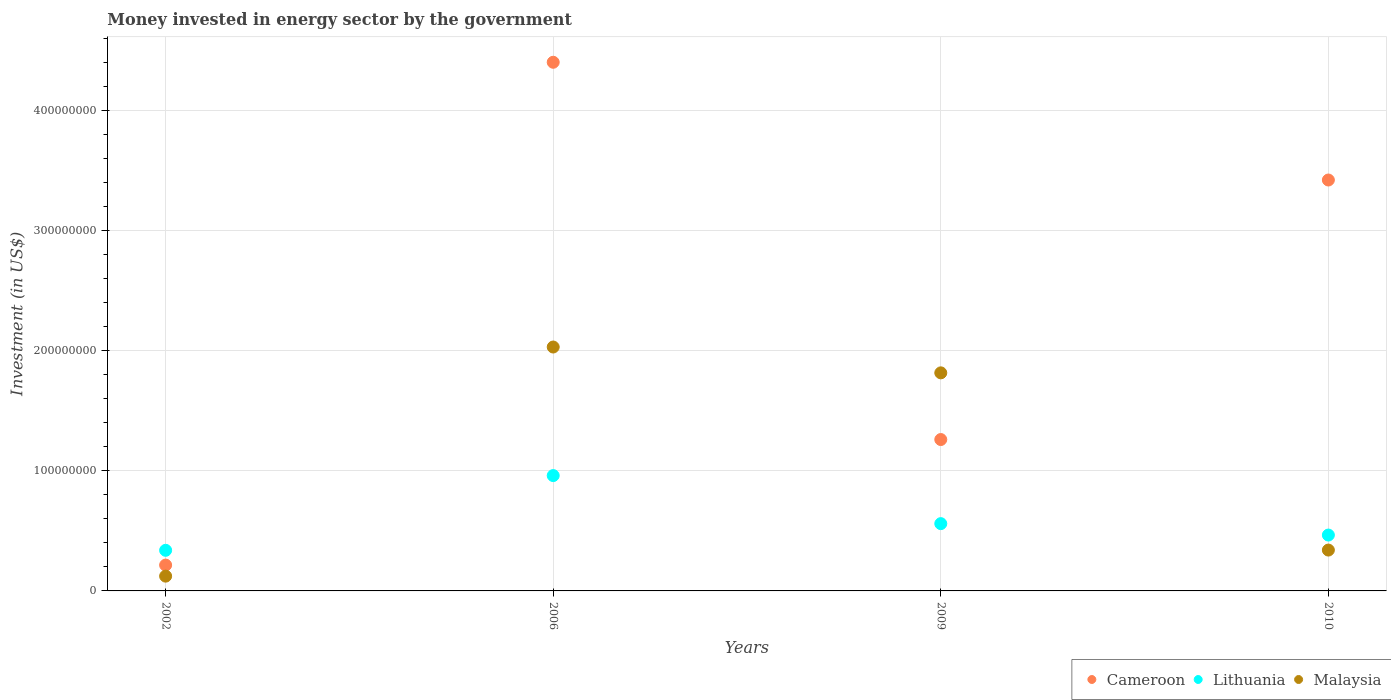What is the money spent in energy sector in Cameroon in 2010?
Offer a terse response. 3.42e+08. Across all years, what is the maximum money spent in energy sector in Malaysia?
Your response must be concise. 2.03e+08. Across all years, what is the minimum money spent in energy sector in Lithuania?
Ensure brevity in your answer.  3.38e+07. What is the total money spent in energy sector in Cameroon in the graph?
Your answer should be compact. 9.30e+08. What is the difference between the money spent in energy sector in Lithuania in 2009 and that in 2010?
Your answer should be very brief. 9.50e+06. What is the difference between the money spent in energy sector in Cameroon in 2006 and the money spent in energy sector in Malaysia in 2002?
Offer a very short reply. 4.28e+08. What is the average money spent in energy sector in Cameroon per year?
Your response must be concise. 2.32e+08. In the year 2009, what is the difference between the money spent in energy sector in Malaysia and money spent in energy sector in Cameroon?
Offer a very short reply. 5.55e+07. In how many years, is the money spent in energy sector in Lithuania greater than 340000000 US$?
Offer a very short reply. 0. What is the ratio of the money spent in energy sector in Malaysia in 2002 to that in 2009?
Make the answer very short. 0.07. Is the money spent in energy sector in Malaysia in 2002 less than that in 2009?
Your answer should be very brief. Yes. Is the difference between the money spent in energy sector in Malaysia in 2002 and 2009 greater than the difference between the money spent in energy sector in Cameroon in 2002 and 2009?
Your answer should be very brief. No. What is the difference between the highest and the second highest money spent in energy sector in Lithuania?
Give a very brief answer. 4.00e+07. What is the difference between the highest and the lowest money spent in energy sector in Lithuania?
Keep it short and to the point. 6.22e+07. Is it the case that in every year, the sum of the money spent in energy sector in Cameroon and money spent in energy sector in Malaysia  is greater than the money spent in energy sector in Lithuania?
Give a very brief answer. No. Are the values on the major ticks of Y-axis written in scientific E-notation?
Keep it short and to the point. No. Where does the legend appear in the graph?
Provide a succinct answer. Bottom right. How are the legend labels stacked?
Make the answer very short. Horizontal. What is the title of the graph?
Ensure brevity in your answer.  Money invested in energy sector by the government. Does "Ethiopia" appear as one of the legend labels in the graph?
Your answer should be compact. No. What is the label or title of the X-axis?
Provide a short and direct response. Years. What is the label or title of the Y-axis?
Provide a short and direct response. Investment (in US$). What is the Investment (in US$) of Cameroon in 2002?
Give a very brief answer. 2.15e+07. What is the Investment (in US$) in Lithuania in 2002?
Ensure brevity in your answer.  3.38e+07. What is the Investment (in US$) of Malaysia in 2002?
Ensure brevity in your answer.  1.23e+07. What is the Investment (in US$) in Cameroon in 2006?
Your response must be concise. 4.40e+08. What is the Investment (in US$) of Lithuania in 2006?
Your answer should be compact. 9.60e+07. What is the Investment (in US$) of Malaysia in 2006?
Offer a very short reply. 2.03e+08. What is the Investment (in US$) in Cameroon in 2009?
Your response must be concise. 1.26e+08. What is the Investment (in US$) in Lithuania in 2009?
Your response must be concise. 5.60e+07. What is the Investment (in US$) of Malaysia in 2009?
Make the answer very short. 1.82e+08. What is the Investment (in US$) in Cameroon in 2010?
Provide a short and direct response. 3.42e+08. What is the Investment (in US$) in Lithuania in 2010?
Offer a terse response. 4.65e+07. What is the Investment (in US$) in Malaysia in 2010?
Give a very brief answer. 3.40e+07. Across all years, what is the maximum Investment (in US$) in Cameroon?
Offer a terse response. 4.40e+08. Across all years, what is the maximum Investment (in US$) of Lithuania?
Offer a very short reply. 9.60e+07. Across all years, what is the maximum Investment (in US$) in Malaysia?
Your answer should be very brief. 2.03e+08. Across all years, what is the minimum Investment (in US$) of Cameroon?
Offer a very short reply. 2.15e+07. Across all years, what is the minimum Investment (in US$) of Lithuania?
Make the answer very short. 3.38e+07. Across all years, what is the minimum Investment (in US$) of Malaysia?
Give a very brief answer. 1.23e+07. What is the total Investment (in US$) of Cameroon in the graph?
Ensure brevity in your answer.  9.30e+08. What is the total Investment (in US$) of Lithuania in the graph?
Your answer should be very brief. 2.32e+08. What is the total Investment (in US$) of Malaysia in the graph?
Your answer should be very brief. 4.31e+08. What is the difference between the Investment (in US$) in Cameroon in 2002 and that in 2006?
Your response must be concise. -4.18e+08. What is the difference between the Investment (in US$) of Lithuania in 2002 and that in 2006?
Make the answer very short. -6.22e+07. What is the difference between the Investment (in US$) of Malaysia in 2002 and that in 2006?
Provide a short and direct response. -1.91e+08. What is the difference between the Investment (in US$) in Cameroon in 2002 and that in 2009?
Keep it short and to the point. -1.04e+08. What is the difference between the Investment (in US$) in Lithuania in 2002 and that in 2009?
Make the answer very short. -2.22e+07. What is the difference between the Investment (in US$) of Malaysia in 2002 and that in 2009?
Your answer should be very brief. -1.69e+08. What is the difference between the Investment (in US$) of Cameroon in 2002 and that in 2010?
Your answer should be compact. -3.20e+08. What is the difference between the Investment (in US$) of Lithuania in 2002 and that in 2010?
Give a very brief answer. -1.27e+07. What is the difference between the Investment (in US$) of Malaysia in 2002 and that in 2010?
Your answer should be very brief. -2.17e+07. What is the difference between the Investment (in US$) of Cameroon in 2006 and that in 2009?
Ensure brevity in your answer.  3.14e+08. What is the difference between the Investment (in US$) in Lithuania in 2006 and that in 2009?
Your response must be concise. 4.00e+07. What is the difference between the Investment (in US$) of Malaysia in 2006 and that in 2009?
Ensure brevity in your answer.  2.15e+07. What is the difference between the Investment (in US$) in Cameroon in 2006 and that in 2010?
Keep it short and to the point. 9.80e+07. What is the difference between the Investment (in US$) in Lithuania in 2006 and that in 2010?
Provide a short and direct response. 4.95e+07. What is the difference between the Investment (in US$) of Malaysia in 2006 and that in 2010?
Keep it short and to the point. 1.69e+08. What is the difference between the Investment (in US$) in Cameroon in 2009 and that in 2010?
Your answer should be very brief. -2.16e+08. What is the difference between the Investment (in US$) in Lithuania in 2009 and that in 2010?
Offer a very short reply. 9.50e+06. What is the difference between the Investment (in US$) of Malaysia in 2009 and that in 2010?
Give a very brief answer. 1.48e+08. What is the difference between the Investment (in US$) in Cameroon in 2002 and the Investment (in US$) in Lithuania in 2006?
Give a very brief answer. -7.45e+07. What is the difference between the Investment (in US$) in Cameroon in 2002 and the Investment (in US$) in Malaysia in 2006?
Your response must be concise. -1.82e+08. What is the difference between the Investment (in US$) in Lithuania in 2002 and the Investment (in US$) in Malaysia in 2006?
Provide a succinct answer. -1.69e+08. What is the difference between the Investment (in US$) in Cameroon in 2002 and the Investment (in US$) in Lithuania in 2009?
Ensure brevity in your answer.  -3.45e+07. What is the difference between the Investment (in US$) in Cameroon in 2002 and the Investment (in US$) in Malaysia in 2009?
Your answer should be very brief. -1.60e+08. What is the difference between the Investment (in US$) of Lithuania in 2002 and the Investment (in US$) of Malaysia in 2009?
Ensure brevity in your answer.  -1.48e+08. What is the difference between the Investment (in US$) of Cameroon in 2002 and the Investment (in US$) of Lithuania in 2010?
Provide a succinct answer. -2.50e+07. What is the difference between the Investment (in US$) of Cameroon in 2002 and the Investment (in US$) of Malaysia in 2010?
Your response must be concise. -1.25e+07. What is the difference between the Investment (in US$) in Lithuania in 2002 and the Investment (in US$) in Malaysia in 2010?
Give a very brief answer. -2.00e+05. What is the difference between the Investment (in US$) of Cameroon in 2006 and the Investment (in US$) of Lithuania in 2009?
Provide a short and direct response. 3.84e+08. What is the difference between the Investment (in US$) of Cameroon in 2006 and the Investment (in US$) of Malaysia in 2009?
Offer a terse response. 2.58e+08. What is the difference between the Investment (in US$) of Lithuania in 2006 and the Investment (in US$) of Malaysia in 2009?
Your response must be concise. -8.55e+07. What is the difference between the Investment (in US$) in Cameroon in 2006 and the Investment (in US$) in Lithuania in 2010?
Offer a very short reply. 3.94e+08. What is the difference between the Investment (in US$) of Cameroon in 2006 and the Investment (in US$) of Malaysia in 2010?
Your answer should be compact. 4.06e+08. What is the difference between the Investment (in US$) of Lithuania in 2006 and the Investment (in US$) of Malaysia in 2010?
Your answer should be compact. 6.20e+07. What is the difference between the Investment (in US$) of Cameroon in 2009 and the Investment (in US$) of Lithuania in 2010?
Make the answer very short. 7.95e+07. What is the difference between the Investment (in US$) in Cameroon in 2009 and the Investment (in US$) in Malaysia in 2010?
Keep it short and to the point. 9.20e+07. What is the difference between the Investment (in US$) in Lithuania in 2009 and the Investment (in US$) in Malaysia in 2010?
Ensure brevity in your answer.  2.20e+07. What is the average Investment (in US$) in Cameroon per year?
Offer a very short reply. 2.32e+08. What is the average Investment (in US$) in Lithuania per year?
Offer a very short reply. 5.81e+07. What is the average Investment (in US$) of Malaysia per year?
Your answer should be compact. 1.08e+08. In the year 2002, what is the difference between the Investment (in US$) in Cameroon and Investment (in US$) in Lithuania?
Provide a short and direct response. -1.23e+07. In the year 2002, what is the difference between the Investment (in US$) in Cameroon and Investment (in US$) in Malaysia?
Provide a succinct answer. 9.20e+06. In the year 2002, what is the difference between the Investment (in US$) in Lithuania and Investment (in US$) in Malaysia?
Ensure brevity in your answer.  2.15e+07. In the year 2006, what is the difference between the Investment (in US$) in Cameroon and Investment (in US$) in Lithuania?
Offer a very short reply. 3.44e+08. In the year 2006, what is the difference between the Investment (in US$) of Cameroon and Investment (in US$) of Malaysia?
Your answer should be very brief. 2.37e+08. In the year 2006, what is the difference between the Investment (in US$) in Lithuania and Investment (in US$) in Malaysia?
Keep it short and to the point. -1.07e+08. In the year 2009, what is the difference between the Investment (in US$) of Cameroon and Investment (in US$) of Lithuania?
Your answer should be compact. 7.00e+07. In the year 2009, what is the difference between the Investment (in US$) of Cameroon and Investment (in US$) of Malaysia?
Your answer should be very brief. -5.55e+07. In the year 2009, what is the difference between the Investment (in US$) in Lithuania and Investment (in US$) in Malaysia?
Offer a very short reply. -1.26e+08. In the year 2010, what is the difference between the Investment (in US$) of Cameroon and Investment (in US$) of Lithuania?
Keep it short and to the point. 2.96e+08. In the year 2010, what is the difference between the Investment (in US$) of Cameroon and Investment (in US$) of Malaysia?
Offer a terse response. 3.08e+08. In the year 2010, what is the difference between the Investment (in US$) in Lithuania and Investment (in US$) in Malaysia?
Offer a very short reply. 1.25e+07. What is the ratio of the Investment (in US$) in Cameroon in 2002 to that in 2006?
Provide a succinct answer. 0.05. What is the ratio of the Investment (in US$) of Lithuania in 2002 to that in 2006?
Your answer should be very brief. 0.35. What is the ratio of the Investment (in US$) of Malaysia in 2002 to that in 2006?
Keep it short and to the point. 0.06. What is the ratio of the Investment (in US$) of Cameroon in 2002 to that in 2009?
Keep it short and to the point. 0.17. What is the ratio of the Investment (in US$) in Lithuania in 2002 to that in 2009?
Offer a terse response. 0.6. What is the ratio of the Investment (in US$) in Malaysia in 2002 to that in 2009?
Provide a succinct answer. 0.07. What is the ratio of the Investment (in US$) in Cameroon in 2002 to that in 2010?
Offer a very short reply. 0.06. What is the ratio of the Investment (in US$) of Lithuania in 2002 to that in 2010?
Your response must be concise. 0.73. What is the ratio of the Investment (in US$) of Malaysia in 2002 to that in 2010?
Ensure brevity in your answer.  0.36. What is the ratio of the Investment (in US$) of Cameroon in 2006 to that in 2009?
Your answer should be compact. 3.49. What is the ratio of the Investment (in US$) of Lithuania in 2006 to that in 2009?
Keep it short and to the point. 1.71. What is the ratio of the Investment (in US$) of Malaysia in 2006 to that in 2009?
Keep it short and to the point. 1.12. What is the ratio of the Investment (in US$) of Cameroon in 2006 to that in 2010?
Your answer should be very brief. 1.29. What is the ratio of the Investment (in US$) of Lithuania in 2006 to that in 2010?
Ensure brevity in your answer.  2.06. What is the ratio of the Investment (in US$) of Malaysia in 2006 to that in 2010?
Keep it short and to the point. 5.97. What is the ratio of the Investment (in US$) in Cameroon in 2009 to that in 2010?
Offer a very short reply. 0.37. What is the ratio of the Investment (in US$) in Lithuania in 2009 to that in 2010?
Make the answer very short. 1.2. What is the ratio of the Investment (in US$) in Malaysia in 2009 to that in 2010?
Offer a terse response. 5.34. What is the difference between the highest and the second highest Investment (in US$) in Cameroon?
Offer a terse response. 9.80e+07. What is the difference between the highest and the second highest Investment (in US$) in Lithuania?
Offer a very short reply. 4.00e+07. What is the difference between the highest and the second highest Investment (in US$) in Malaysia?
Your answer should be very brief. 2.15e+07. What is the difference between the highest and the lowest Investment (in US$) of Cameroon?
Ensure brevity in your answer.  4.18e+08. What is the difference between the highest and the lowest Investment (in US$) of Lithuania?
Offer a very short reply. 6.22e+07. What is the difference between the highest and the lowest Investment (in US$) of Malaysia?
Your answer should be compact. 1.91e+08. 